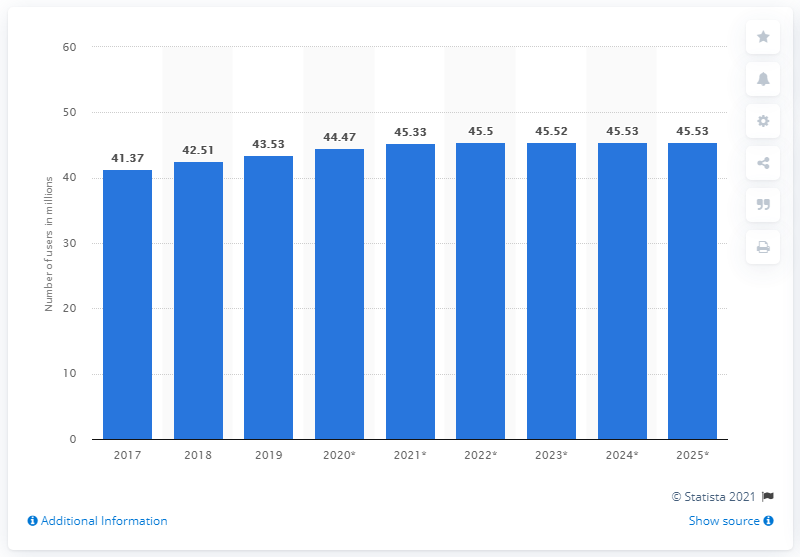Specify some key components in this picture. By 2025, it is estimated that there will be approximately 45.53 million social network users in South Korea. 